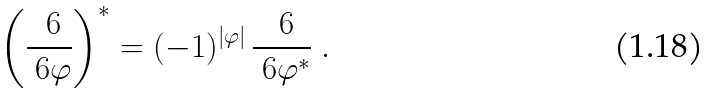<formula> <loc_0><loc_0><loc_500><loc_500>\left ( \frac { \ 6 } { \ 6 \varphi } \right ) ^ { * } = ( - 1 ) ^ { | \varphi | } \, \frac { \ 6 } { \ 6 \varphi ^ { * } } \ .</formula> 